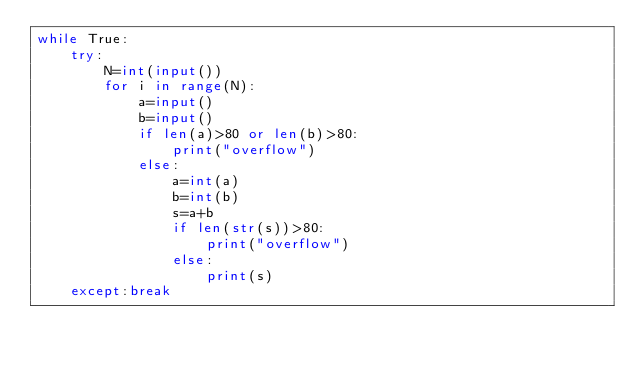<code> <loc_0><loc_0><loc_500><loc_500><_Python_>while True:
    try:
        N=int(input())
        for i in range(N):
            a=input()
            b=input()
            if len(a)>80 or len(b)>80:
                print("overflow")
            else:
                a=int(a)
                b=int(b)
                s=a+b
                if len(str(s))>80:
                    print("overflow")
                else:
                    print(s)
    except:break

</code> 